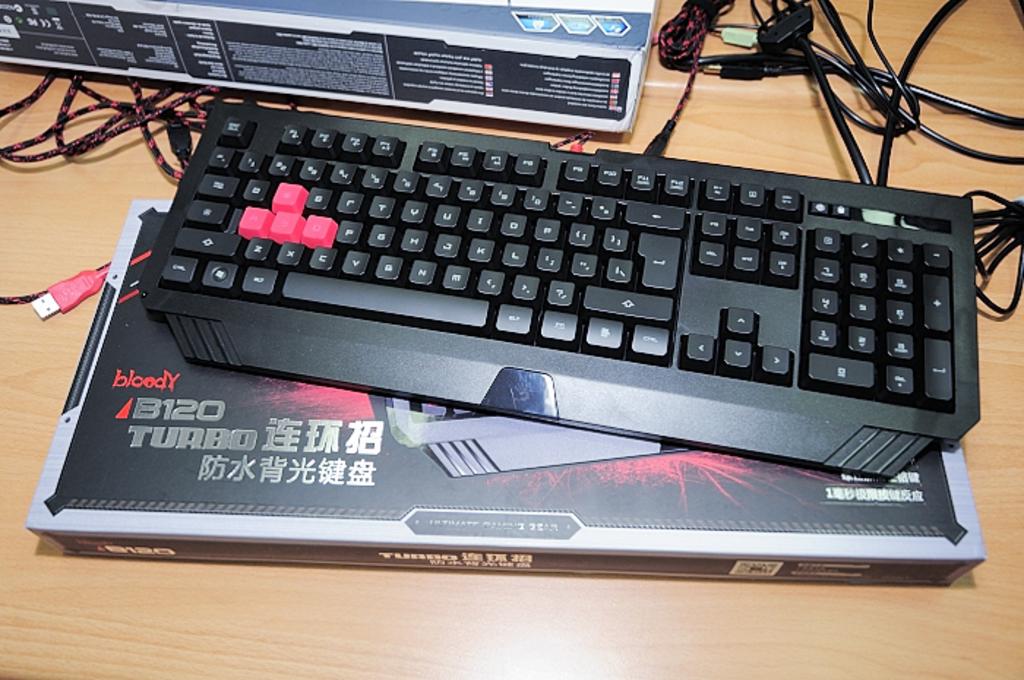Who makes the keyboard?
Offer a terse response. Bloody. What is the name of the keyboard?
Offer a very short reply. B120 turbo. 